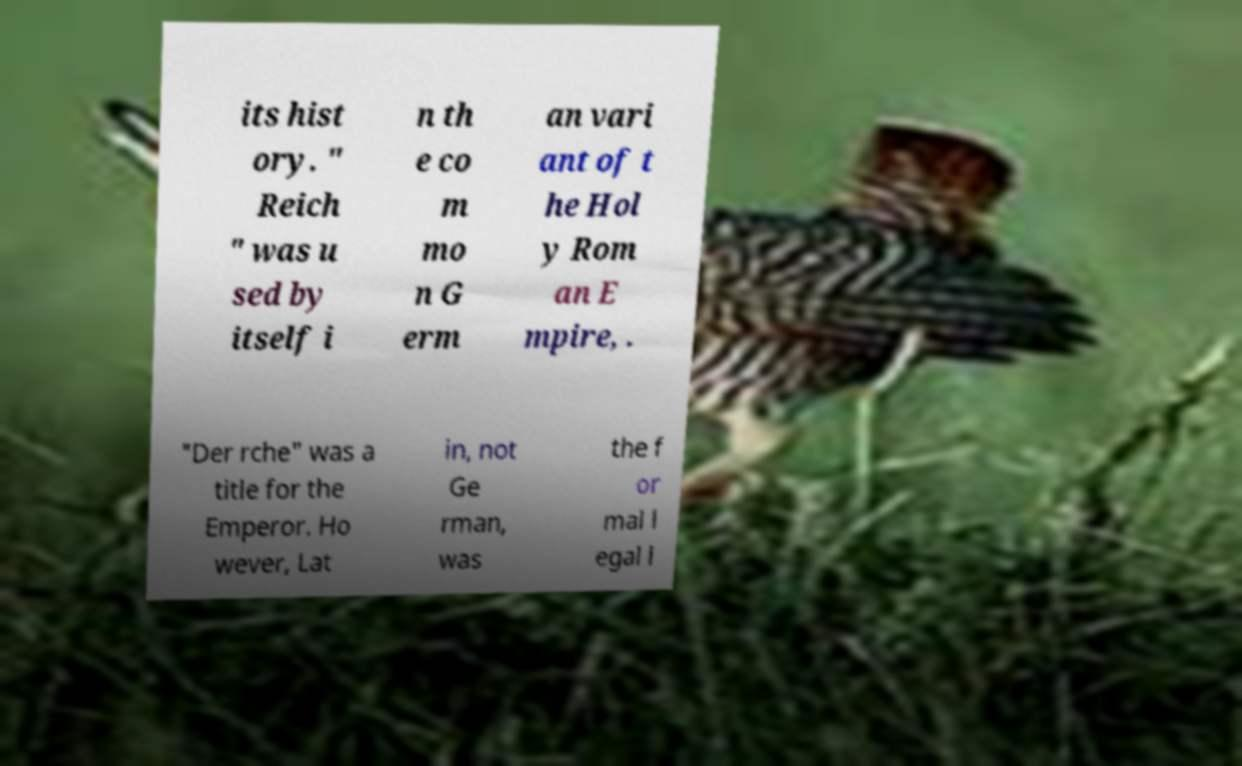Can you accurately transcribe the text from the provided image for me? its hist ory. " Reich " was u sed by itself i n th e co m mo n G erm an vari ant of t he Hol y Rom an E mpire, . "Der rche" was a title for the Emperor. Ho wever, Lat in, not Ge rman, was the f or mal l egal l 